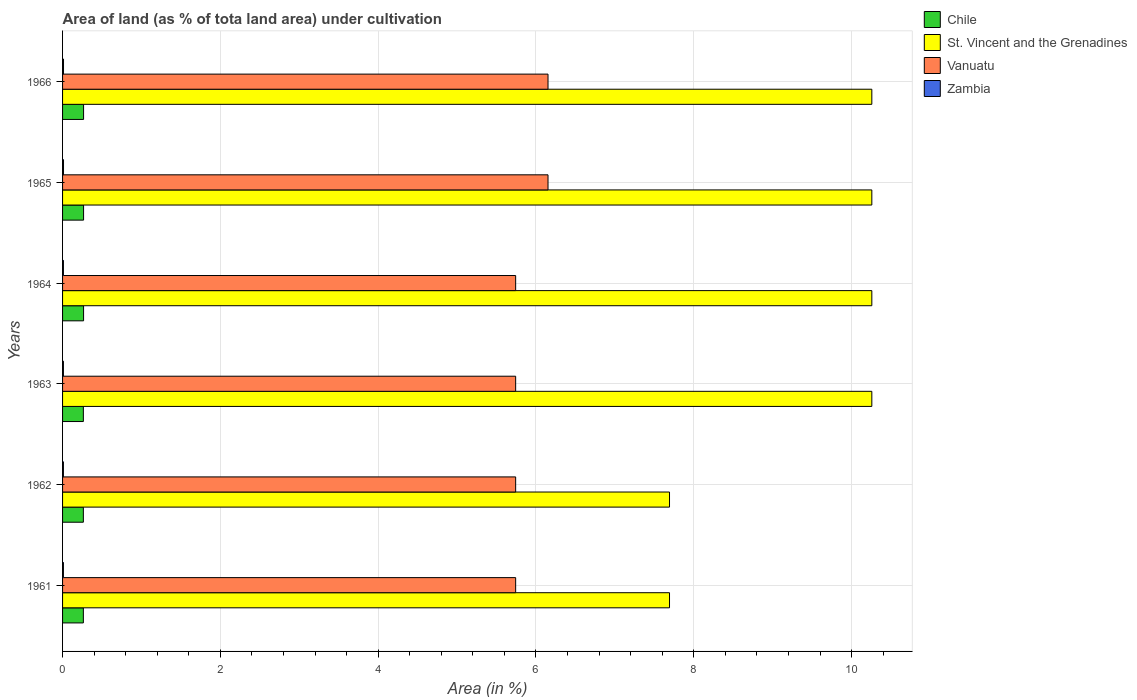How many different coloured bars are there?
Provide a short and direct response. 4. How many groups of bars are there?
Your response must be concise. 6. Are the number of bars per tick equal to the number of legend labels?
Provide a succinct answer. Yes. Are the number of bars on each tick of the Y-axis equal?
Provide a short and direct response. Yes. What is the label of the 4th group of bars from the top?
Your answer should be compact. 1963. In how many cases, is the number of bars for a given year not equal to the number of legend labels?
Offer a terse response. 0. What is the percentage of land under cultivation in St. Vincent and the Grenadines in 1964?
Your response must be concise. 10.26. Across all years, what is the maximum percentage of land under cultivation in Chile?
Keep it short and to the point. 0.27. Across all years, what is the minimum percentage of land under cultivation in Zambia?
Give a very brief answer. 0.01. In which year was the percentage of land under cultivation in Vanuatu maximum?
Provide a succinct answer. 1965. What is the total percentage of land under cultivation in Chile in the graph?
Your response must be concise. 1.59. What is the difference between the percentage of land under cultivation in St. Vincent and the Grenadines in 1963 and that in 1966?
Your response must be concise. 0. What is the difference between the percentage of land under cultivation in Zambia in 1965 and the percentage of land under cultivation in Chile in 1961?
Offer a terse response. -0.25. What is the average percentage of land under cultivation in Zambia per year?
Provide a succinct answer. 0.01. In the year 1961, what is the difference between the percentage of land under cultivation in Chile and percentage of land under cultivation in Zambia?
Your answer should be compact. 0.25. In how many years, is the percentage of land under cultivation in Chile greater than 9.6 %?
Make the answer very short. 0. What is the ratio of the percentage of land under cultivation in Vanuatu in 1963 to that in 1966?
Ensure brevity in your answer.  0.93. What is the difference between the highest and the second highest percentage of land under cultivation in Chile?
Offer a very short reply. 0. What is the difference between the highest and the lowest percentage of land under cultivation in Vanuatu?
Keep it short and to the point. 0.41. Is the sum of the percentage of land under cultivation in St. Vincent and the Grenadines in 1962 and 1963 greater than the maximum percentage of land under cultivation in Vanuatu across all years?
Give a very brief answer. Yes. Is it the case that in every year, the sum of the percentage of land under cultivation in Vanuatu and percentage of land under cultivation in Chile is greater than the sum of percentage of land under cultivation in St. Vincent and the Grenadines and percentage of land under cultivation in Zambia?
Provide a succinct answer. Yes. What does the 2nd bar from the top in 1961 represents?
Make the answer very short. Vanuatu. How many bars are there?
Your response must be concise. 24. Are all the bars in the graph horizontal?
Make the answer very short. Yes. How many years are there in the graph?
Offer a very short reply. 6. What is the difference between two consecutive major ticks on the X-axis?
Ensure brevity in your answer.  2. Does the graph contain grids?
Offer a terse response. Yes. How many legend labels are there?
Offer a terse response. 4. How are the legend labels stacked?
Make the answer very short. Vertical. What is the title of the graph?
Offer a very short reply. Area of land (as % of tota land area) under cultivation. Does "Heavily indebted poor countries" appear as one of the legend labels in the graph?
Provide a short and direct response. No. What is the label or title of the X-axis?
Your response must be concise. Area (in %). What is the label or title of the Y-axis?
Your answer should be very brief. Years. What is the Area (in %) in Chile in 1961?
Ensure brevity in your answer.  0.26. What is the Area (in %) of St. Vincent and the Grenadines in 1961?
Keep it short and to the point. 7.69. What is the Area (in %) in Vanuatu in 1961?
Give a very brief answer. 5.74. What is the Area (in %) of Zambia in 1961?
Give a very brief answer. 0.01. What is the Area (in %) in Chile in 1962?
Provide a succinct answer. 0.26. What is the Area (in %) of St. Vincent and the Grenadines in 1962?
Make the answer very short. 7.69. What is the Area (in %) in Vanuatu in 1962?
Provide a succinct answer. 5.74. What is the Area (in %) in Zambia in 1962?
Provide a short and direct response. 0.01. What is the Area (in %) in Chile in 1963?
Give a very brief answer. 0.26. What is the Area (in %) of St. Vincent and the Grenadines in 1963?
Provide a short and direct response. 10.26. What is the Area (in %) in Vanuatu in 1963?
Your answer should be very brief. 5.74. What is the Area (in %) in Zambia in 1963?
Your answer should be very brief. 0.01. What is the Area (in %) in Chile in 1964?
Make the answer very short. 0.27. What is the Area (in %) in St. Vincent and the Grenadines in 1964?
Offer a very short reply. 10.26. What is the Area (in %) of Vanuatu in 1964?
Your answer should be very brief. 5.74. What is the Area (in %) of Zambia in 1964?
Make the answer very short. 0.01. What is the Area (in %) in Chile in 1965?
Ensure brevity in your answer.  0.27. What is the Area (in %) in St. Vincent and the Grenadines in 1965?
Provide a succinct answer. 10.26. What is the Area (in %) in Vanuatu in 1965?
Give a very brief answer. 6.15. What is the Area (in %) in Zambia in 1965?
Offer a terse response. 0.01. What is the Area (in %) in Chile in 1966?
Provide a short and direct response. 0.27. What is the Area (in %) of St. Vincent and the Grenadines in 1966?
Your answer should be very brief. 10.26. What is the Area (in %) of Vanuatu in 1966?
Provide a short and direct response. 6.15. What is the Area (in %) in Zambia in 1966?
Offer a terse response. 0.01. Across all years, what is the maximum Area (in %) of Chile?
Ensure brevity in your answer.  0.27. Across all years, what is the maximum Area (in %) in St. Vincent and the Grenadines?
Provide a succinct answer. 10.26. Across all years, what is the maximum Area (in %) of Vanuatu?
Make the answer very short. 6.15. Across all years, what is the maximum Area (in %) in Zambia?
Your answer should be very brief. 0.01. Across all years, what is the minimum Area (in %) in Chile?
Provide a succinct answer. 0.26. Across all years, what is the minimum Area (in %) of St. Vincent and the Grenadines?
Your response must be concise. 7.69. Across all years, what is the minimum Area (in %) in Vanuatu?
Provide a short and direct response. 5.74. Across all years, what is the minimum Area (in %) in Zambia?
Your answer should be compact. 0.01. What is the total Area (in %) of Chile in the graph?
Make the answer very short. 1.59. What is the total Area (in %) in St. Vincent and the Grenadines in the graph?
Your answer should be very brief. 56.41. What is the total Area (in %) in Vanuatu in the graph?
Provide a succinct answer. 35.27. What is the total Area (in %) in Zambia in the graph?
Your response must be concise. 0.07. What is the difference between the Area (in %) in Chile in 1961 and that in 1962?
Provide a succinct answer. 0. What is the difference between the Area (in %) of Chile in 1961 and that in 1963?
Provide a succinct answer. 0. What is the difference between the Area (in %) in St. Vincent and the Grenadines in 1961 and that in 1963?
Give a very brief answer. -2.56. What is the difference between the Area (in %) of Chile in 1961 and that in 1964?
Make the answer very short. -0. What is the difference between the Area (in %) of St. Vincent and the Grenadines in 1961 and that in 1964?
Offer a terse response. -2.56. What is the difference between the Area (in %) of Zambia in 1961 and that in 1964?
Offer a very short reply. 0. What is the difference between the Area (in %) in Chile in 1961 and that in 1965?
Ensure brevity in your answer.  -0. What is the difference between the Area (in %) of St. Vincent and the Grenadines in 1961 and that in 1965?
Your answer should be compact. -2.56. What is the difference between the Area (in %) of Vanuatu in 1961 and that in 1965?
Provide a short and direct response. -0.41. What is the difference between the Area (in %) in Zambia in 1961 and that in 1965?
Provide a short and direct response. -0. What is the difference between the Area (in %) in Chile in 1961 and that in 1966?
Make the answer very short. -0. What is the difference between the Area (in %) in St. Vincent and the Grenadines in 1961 and that in 1966?
Your answer should be very brief. -2.56. What is the difference between the Area (in %) of Vanuatu in 1961 and that in 1966?
Your answer should be compact. -0.41. What is the difference between the Area (in %) in Zambia in 1961 and that in 1966?
Keep it short and to the point. -0. What is the difference between the Area (in %) in St. Vincent and the Grenadines in 1962 and that in 1963?
Make the answer very short. -2.56. What is the difference between the Area (in %) in Chile in 1962 and that in 1964?
Keep it short and to the point. -0. What is the difference between the Area (in %) in St. Vincent and the Grenadines in 1962 and that in 1964?
Offer a terse response. -2.56. What is the difference between the Area (in %) of Vanuatu in 1962 and that in 1964?
Provide a succinct answer. 0. What is the difference between the Area (in %) in Chile in 1962 and that in 1965?
Your answer should be very brief. -0. What is the difference between the Area (in %) in St. Vincent and the Grenadines in 1962 and that in 1965?
Provide a succinct answer. -2.56. What is the difference between the Area (in %) in Vanuatu in 1962 and that in 1965?
Offer a terse response. -0.41. What is the difference between the Area (in %) in Zambia in 1962 and that in 1965?
Provide a short and direct response. -0. What is the difference between the Area (in %) in Chile in 1962 and that in 1966?
Offer a very short reply. -0. What is the difference between the Area (in %) in St. Vincent and the Grenadines in 1962 and that in 1966?
Keep it short and to the point. -2.56. What is the difference between the Area (in %) in Vanuatu in 1962 and that in 1966?
Offer a terse response. -0.41. What is the difference between the Area (in %) of Zambia in 1962 and that in 1966?
Keep it short and to the point. -0. What is the difference between the Area (in %) in Chile in 1963 and that in 1964?
Make the answer very short. -0. What is the difference between the Area (in %) of St. Vincent and the Grenadines in 1963 and that in 1964?
Your answer should be compact. 0. What is the difference between the Area (in %) in Zambia in 1963 and that in 1964?
Give a very brief answer. 0. What is the difference between the Area (in %) of Chile in 1963 and that in 1965?
Provide a succinct answer. -0. What is the difference between the Area (in %) of St. Vincent and the Grenadines in 1963 and that in 1965?
Provide a short and direct response. 0. What is the difference between the Area (in %) in Vanuatu in 1963 and that in 1965?
Ensure brevity in your answer.  -0.41. What is the difference between the Area (in %) of Zambia in 1963 and that in 1965?
Keep it short and to the point. -0. What is the difference between the Area (in %) of Chile in 1963 and that in 1966?
Your response must be concise. -0. What is the difference between the Area (in %) in St. Vincent and the Grenadines in 1963 and that in 1966?
Make the answer very short. 0. What is the difference between the Area (in %) in Vanuatu in 1963 and that in 1966?
Your answer should be very brief. -0.41. What is the difference between the Area (in %) of Zambia in 1963 and that in 1966?
Ensure brevity in your answer.  -0. What is the difference between the Area (in %) of St. Vincent and the Grenadines in 1964 and that in 1965?
Offer a very short reply. 0. What is the difference between the Area (in %) in Vanuatu in 1964 and that in 1965?
Provide a succinct answer. -0.41. What is the difference between the Area (in %) of Zambia in 1964 and that in 1965?
Ensure brevity in your answer.  -0. What is the difference between the Area (in %) in St. Vincent and the Grenadines in 1964 and that in 1966?
Keep it short and to the point. 0. What is the difference between the Area (in %) of Vanuatu in 1964 and that in 1966?
Ensure brevity in your answer.  -0.41. What is the difference between the Area (in %) in Zambia in 1964 and that in 1966?
Give a very brief answer. -0. What is the difference between the Area (in %) of Chile in 1965 and that in 1966?
Make the answer very short. 0. What is the difference between the Area (in %) in St. Vincent and the Grenadines in 1965 and that in 1966?
Offer a terse response. 0. What is the difference between the Area (in %) of Chile in 1961 and the Area (in %) of St. Vincent and the Grenadines in 1962?
Make the answer very short. -7.43. What is the difference between the Area (in %) in Chile in 1961 and the Area (in %) in Vanuatu in 1962?
Offer a terse response. -5.48. What is the difference between the Area (in %) in Chile in 1961 and the Area (in %) in Zambia in 1962?
Keep it short and to the point. 0.25. What is the difference between the Area (in %) of St. Vincent and the Grenadines in 1961 and the Area (in %) of Vanuatu in 1962?
Your answer should be compact. 1.95. What is the difference between the Area (in %) in St. Vincent and the Grenadines in 1961 and the Area (in %) in Zambia in 1962?
Your response must be concise. 7.68. What is the difference between the Area (in %) of Vanuatu in 1961 and the Area (in %) of Zambia in 1962?
Your response must be concise. 5.73. What is the difference between the Area (in %) in Chile in 1961 and the Area (in %) in St. Vincent and the Grenadines in 1963?
Give a very brief answer. -9.99. What is the difference between the Area (in %) in Chile in 1961 and the Area (in %) in Vanuatu in 1963?
Keep it short and to the point. -5.48. What is the difference between the Area (in %) of Chile in 1961 and the Area (in %) of Zambia in 1963?
Your response must be concise. 0.25. What is the difference between the Area (in %) of St. Vincent and the Grenadines in 1961 and the Area (in %) of Vanuatu in 1963?
Your answer should be compact. 1.95. What is the difference between the Area (in %) of St. Vincent and the Grenadines in 1961 and the Area (in %) of Zambia in 1963?
Make the answer very short. 7.68. What is the difference between the Area (in %) in Vanuatu in 1961 and the Area (in %) in Zambia in 1963?
Your answer should be compact. 5.73. What is the difference between the Area (in %) in Chile in 1961 and the Area (in %) in St. Vincent and the Grenadines in 1964?
Make the answer very short. -9.99. What is the difference between the Area (in %) in Chile in 1961 and the Area (in %) in Vanuatu in 1964?
Ensure brevity in your answer.  -5.48. What is the difference between the Area (in %) in Chile in 1961 and the Area (in %) in Zambia in 1964?
Offer a terse response. 0.25. What is the difference between the Area (in %) of St. Vincent and the Grenadines in 1961 and the Area (in %) of Vanuatu in 1964?
Ensure brevity in your answer.  1.95. What is the difference between the Area (in %) of St. Vincent and the Grenadines in 1961 and the Area (in %) of Zambia in 1964?
Offer a very short reply. 7.68. What is the difference between the Area (in %) of Vanuatu in 1961 and the Area (in %) of Zambia in 1964?
Give a very brief answer. 5.73. What is the difference between the Area (in %) of Chile in 1961 and the Area (in %) of St. Vincent and the Grenadines in 1965?
Keep it short and to the point. -9.99. What is the difference between the Area (in %) of Chile in 1961 and the Area (in %) of Vanuatu in 1965?
Offer a terse response. -5.89. What is the difference between the Area (in %) of Chile in 1961 and the Area (in %) of Zambia in 1965?
Offer a terse response. 0.25. What is the difference between the Area (in %) in St. Vincent and the Grenadines in 1961 and the Area (in %) in Vanuatu in 1965?
Offer a very short reply. 1.54. What is the difference between the Area (in %) in St. Vincent and the Grenadines in 1961 and the Area (in %) in Zambia in 1965?
Your response must be concise. 7.68. What is the difference between the Area (in %) in Vanuatu in 1961 and the Area (in %) in Zambia in 1965?
Provide a short and direct response. 5.73. What is the difference between the Area (in %) in Chile in 1961 and the Area (in %) in St. Vincent and the Grenadines in 1966?
Your answer should be compact. -9.99. What is the difference between the Area (in %) of Chile in 1961 and the Area (in %) of Vanuatu in 1966?
Make the answer very short. -5.89. What is the difference between the Area (in %) in Chile in 1961 and the Area (in %) in Zambia in 1966?
Offer a very short reply. 0.25. What is the difference between the Area (in %) in St. Vincent and the Grenadines in 1961 and the Area (in %) in Vanuatu in 1966?
Offer a terse response. 1.54. What is the difference between the Area (in %) in St. Vincent and the Grenadines in 1961 and the Area (in %) in Zambia in 1966?
Your answer should be very brief. 7.68. What is the difference between the Area (in %) in Vanuatu in 1961 and the Area (in %) in Zambia in 1966?
Provide a short and direct response. 5.73. What is the difference between the Area (in %) of Chile in 1962 and the Area (in %) of St. Vincent and the Grenadines in 1963?
Ensure brevity in your answer.  -9.99. What is the difference between the Area (in %) of Chile in 1962 and the Area (in %) of Vanuatu in 1963?
Offer a terse response. -5.48. What is the difference between the Area (in %) of Chile in 1962 and the Area (in %) of Zambia in 1963?
Offer a terse response. 0.25. What is the difference between the Area (in %) of St. Vincent and the Grenadines in 1962 and the Area (in %) of Vanuatu in 1963?
Your answer should be very brief. 1.95. What is the difference between the Area (in %) of St. Vincent and the Grenadines in 1962 and the Area (in %) of Zambia in 1963?
Provide a succinct answer. 7.68. What is the difference between the Area (in %) in Vanuatu in 1962 and the Area (in %) in Zambia in 1963?
Keep it short and to the point. 5.73. What is the difference between the Area (in %) of Chile in 1962 and the Area (in %) of St. Vincent and the Grenadines in 1964?
Your response must be concise. -9.99. What is the difference between the Area (in %) of Chile in 1962 and the Area (in %) of Vanuatu in 1964?
Give a very brief answer. -5.48. What is the difference between the Area (in %) of Chile in 1962 and the Area (in %) of Zambia in 1964?
Ensure brevity in your answer.  0.25. What is the difference between the Area (in %) of St. Vincent and the Grenadines in 1962 and the Area (in %) of Vanuatu in 1964?
Your response must be concise. 1.95. What is the difference between the Area (in %) in St. Vincent and the Grenadines in 1962 and the Area (in %) in Zambia in 1964?
Your answer should be compact. 7.68. What is the difference between the Area (in %) of Vanuatu in 1962 and the Area (in %) of Zambia in 1964?
Provide a succinct answer. 5.73. What is the difference between the Area (in %) of Chile in 1962 and the Area (in %) of St. Vincent and the Grenadines in 1965?
Make the answer very short. -9.99. What is the difference between the Area (in %) in Chile in 1962 and the Area (in %) in Vanuatu in 1965?
Your answer should be very brief. -5.89. What is the difference between the Area (in %) of Chile in 1962 and the Area (in %) of Zambia in 1965?
Your answer should be compact. 0.25. What is the difference between the Area (in %) of St. Vincent and the Grenadines in 1962 and the Area (in %) of Vanuatu in 1965?
Offer a very short reply. 1.54. What is the difference between the Area (in %) in St. Vincent and the Grenadines in 1962 and the Area (in %) in Zambia in 1965?
Keep it short and to the point. 7.68. What is the difference between the Area (in %) of Vanuatu in 1962 and the Area (in %) of Zambia in 1965?
Offer a terse response. 5.73. What is the difference between the Area (in %) in Chile in 1962 and the Area (in %) in St. Vincent and the Grenadines in 1966?
Make the answer very short. -9.99. What is the difference between the Area (in %) of Chile in 1962 and the Area (in %) of Vanuatu in 1966?
Keep it short and to the point. -5.89. What is the difference between the Area (in %) of Chile in 1962 and the Area (in %) of Zambia in 1966?
Give a very brief answer. 0.25. What is the difference between the Area (in %) in St. Vincent and the Grenadines in 1962 and the Area (in %) in Vanuatu in 1966?
Give a very brief answer. 1.54. What is the difference between the Area (in %) of St. Vincent and the Grenadines in 1962 and the Area (in %) of Zambia in 1966?
Your answer should be compact. 7.68. What is the difference between the Area (in %) in Vanuatu in 1962 and the Area (in %) in Zambia in 1966?
Ensure brevity in your answer.  5.73. What is the difference between the Area (in %) of Chile in 1963 and the Area (in %) of St. Vincent and the Grenadines in 1964?
Provide a short and direct response. -9.99. What is the difference between the Area (in %) of Chile in 1963 and the Area (in %) of Vanuatu in 1964?
Offer a very short reply. -5.48. What is the difference between the Area (in %) in Chile in 1963 and the Area (in %) in Zambia in 1964?
Ensure brevity in your answer.  0.25. What is the difference between the Area (in %) in St. Vincent and the Grenadines in 1963 and the Area (in %) in Vanuatu in 1964?
Make the answer very short. 4.51. What is the difference between the Area (in %) of St. Vincent and the Grenadines in 1963 and the Area (in %) of Zambia in 1964?
Ensure brevity in your answer.  10.25. What is the difference between the Area (in %) of Vanuatu in 1963 and the Area (in %) of Zambia in 1964?
Offer a very short reply. 5.73. What is the difference between the Area (in %) in Chile in 1963 and the Area (in %) in St. Vincent and the Grenadines in 1965?
Keep it short and to the point. -9.99. What is the difference between the Area (in %) of Chile in 1963 and the Area (in %) of Vanuatu in 1965?
Offer a very short reply. -5.89. What is the difference between the Area (in %) of Chile in 1963 and the Area (in %) of Zambia in 1965?
Offer a terse response. 0.25. What is the difference between the Area (in %) of St. Vincent and the Grenadines in 1963 and the Area (in %) of Vanuatu in 1965?
Offer a terse response. 4.1. What is the difference between the Area (in %) of St. Vincent and the Grenadines in 1963 and the Area (in %) of Zambia in 1965?
Offer a terse response. 10.24. What is the difference between the Area (in %) in Vanuatu in 1963 and the Area (in %) in Zambia in 1965?
Your answer should be compact. 5.73. What is the difference between the Area (in %) of Chile in 1963 and the Area (in %) of St. Vincent and the Grenadines in 1966?
Provide a short and direct response. -9.99. What is the difference between the Area (in %) of Chile in 1963 and the Area (in %) of Vanuatu in 1966?
Your response must be concise. -5.89. What is the difference between the Area (in %) of Chile in 1963 and the Area (in %) of Zambia in 1966?
Provide a short and direct response. 0.25. What is the difference between the Area (in %) of St. Vincent and the Grenadines in 1963 and the Area (in %) of Vanuatu in 1966?
Keep it short and to the point. 4.1. What is the difference between the Area (in %) of St. Vincent and the Grenadines in 1963 and the Area (in %) of Zambia in 1966?
Your answer should be compact. 10.24. What is the difference between the Area (in %) in Vanuatu in 1963 and the Area (in %) in Zambia in 1966?
Your answer should be very brief. 5.73. What is the difference between the Area (in %) of Chile in 1964 and the Area (in %) of St. Vincent and the Grenadines in 1965?
Your response must be concise. -9.99. What is the difference between the Area (in %) of Chile in 1964 and the Area (in %) of Vanuatu in 1965?
Keep it short and to the point. -5.89. What is the difference between the Area (in %) in Chile in 1964 and the Area (in %) in Zambia in 1965?
Offer a terse response. 0.25. What is the difference between the Area (in %) of St. Vincent and the Grenadines in 1964 and the Area (in %) of Vanuatu in 1965?
Your answer should be very brief. 4.1. What is the difference between the Area (in %) of St. Vincent and the Grenadines in 1964 and the Area (in %) of Zambia in 1965?
Offer a terse response. 10.24. What is the difference between the Area (in %) in Vanuatu in 1964 and the Area (in %) in Zambia in 1965?
Provide a short and direct response. 5.73. What is the difference between the Area (in %) in Chile in 1964 and the Area (in %) in St. Vincent and the Grenadines in 1966?
Make the answer very short. -9.99. What is the difference between the Area (in %) in Chile in 1964 and the Area (in %) in Vanuatu in 1966?
Keep it short and to the point. -5.89. What is the difference between the Area (in %) of Chile in 1964 and the Area (in %) of Zambia in 1966?
Give a very brief answer. 0.25. What is the difference between the Area (in %) in St. Vincent and the Grenadines in 1964 and the Area (in %) in Vanuatu in 1966?
Keep it short and to the point. 4.1. What is the difference between the Area (in %) of St. Vincent and the Grenadines in 1964 and the Area (in %) of Zambia in 1966?
Your answer should be very brief. 10.24. What is the difference between the Area (in %) in Vanuatu in 1964 and the Area (in %) in Zambia in 1966?
Your answer should be compact. 5.73. What is the difference between the Area (in %) in Chile in 1965 and the Area (in %) in St. Vincent and the Grenadines in 1966?
Offer a terse response. -9.99. What is the difference between the Area (in %) in Chile in 1965 and the Area (in %) in Vanuatu in 1966?
Your response must be concise. -5.89. What is the difference between the Area (in %) in Chile in 1965 and the Area (in %) in Zambia in 1966?
Your answer should be very brief. 0.25. What is the difference between the Area (in %) in St. Vincent and the Grenadines in 1965 and the Area (in %) in Vanuatu in 1966?
Your answer should be very brief. 4.1. What is the difference between the Area (in %) of St. Vincent and the Grenadines in 1965 and the Area (in %) of Zambia in 1966?
Offer a terse response. 10.24. What is the difference between the Area (in %) in Vanuatu in 1965 and the Area (in %) in Zambia in 1966?
Make the answer very short. 6.14. What is the average Area (in %) in Chile per year?
Your response must be concise. 0.27. What is the average Area (in %) of St. Vincent and the Grenadines per year?
Your response must be concise. 9.4. What is the average Area (in %) in Vanuatu per year?
Give a very brief answer. 5.88. What is the average Area (in %) in Zambia per year?
Ensure brevity in your answer.  0.01. In the year 1961, what is the difference between the Area (in %) in Chile and Area (in %) in St. Vincent and the Grenadines?
Your response must be concise. -7.43. In the year 1961, what is the difference between the Area (in %) of Chile and Area (in %) of Vanuatu?
Ensure brevity in your answer.  -5.48. In the year 1961, what is the difference between the Area (in %) of Chile and Area (in %) of Zambia?
Ensure brevity in your answer.  0.25. In the year 1961, what is the difference between the Area (in %) in St. Vincent and the Grenadines and Area (in %) in Vanuatu?
Your response must be concise. 1.95. In the year 1961, what is the difference between the Area (in %) in St. Vincent and the Grenadines and Area (in %) in Zambia?
Provide a short and direct response. 7.68. In the year 1961, what is the difference between the Area (in %) of Vanuatu and Area (in %) of Zambia?
Offer a terse response. 5.73. In the year 1962, what is the difference between the Area (in %) of Chile and Area (in %) of St. Vincent and the Grenadines?
Your response must be concise. -7.43. In the year 1962, what is the difference between the Area (in %) of Chile and Area (in %) of Vanuatu?
Keep it short and to the point. -5.48. In the year 1962, what is the difference between the Area (in %) of Chile and Area (in %) of Zambia?
Ensure brevity in your answer.  0.25. In the year 1962, what is the difference between the Area (in %) of St. Vincent and the Grenadines and Area (in %) of Vanuatu?
Provide a short and direct response. 1.95. In the year 1962, what is the difference between the Area (in %) in St. Vincent and the Grenadines and Area (in %) in Zambia?
Give a very brief answer. 7.68. In the year 1962, what is the difference between the Area (in %) in Vanuatu and Area (in %) in Zambia?
Make the answer very short. 5.73. In the year 1963, what is the difference between the Area (in %) in Chile and Area (in %) in St. Vincent and the Grenadines?
Give a very brief answer. -9.99. In the year 1963, what is the difference between the Area (in %) of Chile and Area (in %) of Vanuatu?
Give a very brief answer. -5.48. In the year 1963, what is the difference between the Area (in %) of Chile and Area (in %) of Zambia?
Give a very brief answer. 0.25. In the year 1963, what is the difference between the Area (in %) of St. Vincent and the Grenadines and Area (in %) of Vanuatu?
Keep it short and to the point. 4.51. In the year 1963, what is the difference between the Area (in %) of St. Vincent and the Grenadines and Area (in %) of Zambia?
Ensure brevity in your answer.  10.25. In the year 1963, what is the difference between the Area (in %) in Vanuatu and Area (in %) in Zambia?
Make the answer very short. 5.73. In the year 1964, what is the difference between the Area (in %) in Chile and Area (in %) in St. Vincent and the Grenadines?
Your answer should be very brief. -9.99. In the year 1964, what is the difference between the Area (in %) of Chile and Area (in %) of Vanuatu?
Provide a succinct answer. -5.48. In the year 1964, what is the difference between the Area (in %) in Chile and Area (in %) in Zambia?
Make the answer very short. 0.26. In the year 1964, what is the difference between the Area (in %) of St. Vincent and the Grenadines and Area (in %) of Vanuatu?
Give a very brief answer. 4.51. In the year 1964, what is the difference between the Area (in %) in St. Vincent and the Grenadines and Area (in %) in Zambia?
Keep it short and to the point. 10.25. In the year 1964, what is the difference between the Area (in %) in Vanuatu and Area (in %) in Zambia?
Give a very brief answer. 5.73. In the year 1965, what is the difference between the Area (in %) of Chile and Area (in %) of St. Vincent and the Grenadines?
Ensure brevity in your answer.  -9.99. In the year 1965, what is the difference between the Area (in %) of Chile and Area (in %) of Vanuatu?
Make the answer very short. -5.89. In the year 1965, what is the difference between the Area (in %) of Chile and Area (in %) of Zambia?
Offer a terse response. 0.25. In the year 1965, what is the difference between the Area (in %) in St. Vincent and the Grenadines and Area (in %) in Vanuatu?
Provide a succinct answer. 4.1. In the year 1965, what is the difference between the Area (in %) of St. Vincent and the Grenadines and Area (in %) of Zambia?
Keep it short and to the point. 10.24. In the year 1965, what is the difference between the Area (in %) of Vanuatu and Area (in %) of Zambia?
Your answer should be very brief. 6.14. In the year 1966, what is the difference between the Area (in %) of Chile and Area (in %) of St. Vincent and the Grenadines?
Provide a succinct answer. -9.99. In the year 1966, what is the difference between the Area (in %) of Chile and Area (in %) of Vanuatu?
Give a very brief answer. -5.89. In the year 1966, what is the difference between the Area (in %) in Chile and Area (in %) in Zambia?
Offer a very short reply. 0.25. In the year 1966, what is the difference between the Area (in %) in St. Vincent and the Grenadines and Area (in %) in Vanuatu?
Offer a terse response. 4.1. In the year 1966, what is the difference between the Area (in %) of St. Vincent and the Grenadines and Area (in %) of Zambia?
Provide a short and direct response. 10.24. In the year 1966, what is the difference between the Area (in %) in Vanuatu and Area (in %) in Zambia?
Provide a short and direct response. 6.14. What is the ratio of the Area (in %) in Chile in 1961 to that in 1963?
Give a very brief answer. 1. What is the ratio of the Area (in %) in St. Vincent and the Grenadines in 1961 to that in 1963?
Make the answer very short. 0.75. What is the ratio of the Area (in %) in Zambia in 1961 to that in 1963?
Provide a short and direct response. 1. What is the ratio of the Area (in %) of Chile in 1961 to that in 1964?
Provide a short and direct response. 0.99. What is the ratio of the Area (in %) of Zambia in 1961 to that in 1964?
Your response must be concise. 1. What is the ratio of the Area (in %) of Vanuatu in 1961 to that in 1965?
Provide a short and direct response. 0.93. What is the ratio of the Area (in %) in Zambia in 1961 to that in 1965?
Make the answer very short. 0.89. What is the ratio of the Area (in %) in Chile in 1961 to that in 1966?
Keep it short and to the point. 0.99. What is the ratio of the Area (in %) in Vanuatu in 1961 to that in 1966?
Your answer should be very brief. 0.93. What is the ratio of the Area (in %) of Chile in 1962 to that in 1963?
Give a very brief answer. 1. What is the ratio of the Area (in %) in St. Vincent and the Grenadines in 1962 to that in 1963?
Your answer should be compact. 0.75. What is the ratio of the Area (in %) in Vanuatu in 1962 to that in 1963?
Provide a succinct answer. 1. What is the ratio of the Area (in %) in Chile in 1962 to that in 1964?
Offer a terse response. 0.99. What is the ratio of the Area (in %) of Vanuatu in 1962 to that in 1964?
Make the answer very short. 1. What is the ratio of the Area (in %) of Zambia in 1962 to that in 1964?
Offer a very short reply. 1. What is the ratio of the Area (in %) in Chile in 1962 to that in 1965?
Your answer should be compact. 0.99. What is the ratio of the Area (in %) of St. Vincent and the Grenadines in 1962 to that in 1965?
Make the answer very short. 0.75. What is the ratio of the Area (in %) of Vanuatu in 1962 to that in 1965?
Ensure brevity in your answer.  0.93. What is the ratio of the Area (in %) of Zambia in 1962 to that in 1965?
Offer a terse response. 0.89. What is the ratio of the Area (in %) in Chile in 1962 to that in 1966?
Provide a short and direct response. 0.99. What is the ratio of the Area (in %) of Zambia in 1962 to that in 1966?
Keep it short and to the point. 0.89. What is the ratio of the Area (in %) of Chile in 1963 to that in 1964?
Keep it short and to the point. 0.99. What is the ratio of the Area (in %) of St. Vincent and the Grenadines in 1963 to that in 1964?
Give a very brief answer. 1. What is the ratio of the Area (in %) in Vanuatu in 1963 to that in 1964?
Ensure brevity in your answer.  1. What is the ratio of the Area (in %) in Vanuatu in 1963 to that in 1965?
Ensure brevity in your answer.  0.93. What is the ratio of the Area (in %) in Zambia in 1963 to that in 1966?
Your response must be concise. 0.89. What is the ratio of the Area (in %) of Vanuatu in 1964 to that in 1965?
Offer a terse response. 0.93. What is the ratio of the Area (in %) of Chile in 1964 to that in 1966?
Provide a succinct answer. 1. What is the ratio of the Area (in %) in St. Vincent and the Grenadines in 1964 to that in 1966?
Your response must be concise. 1. What is the ratio of the Area (in %) of Chile in 1965 to that in 1966?
Keep it short and to the point. 1. What is the ratio of the Area (in %) in St. Vincent and the Grenadines in 1965 to that in 1966?
Your answer should be very brief. 1. What is the difference between the highest and the second highest Area (in %) in Chile?
Ensure brevity in your answer.  0. What is the difference between the highest and the second highest Area (in %) in St. Vincent and the Grenadines?
Ensure brevity in your answer.  0. What is the difference between the highest and the second highest Area (in %) of Zambia?
Your response must be concise. 0. What is the difference between the highest and the lowest Area (in %) of Chile?
Your answer should be very brief. 0. What is the difference between the highest and the lowest Area (in %) of St. Vincent and the Grenadines?
Ensure brevity in your answer.  2.56. What is the difference between the highest and the lowest Area (in %) in Vanuatu?
Provide a succinct answer. 0.41. What is the difference between the highest and the lowest Area (in %) in Zambia?
Your answer should be compact. 0. 